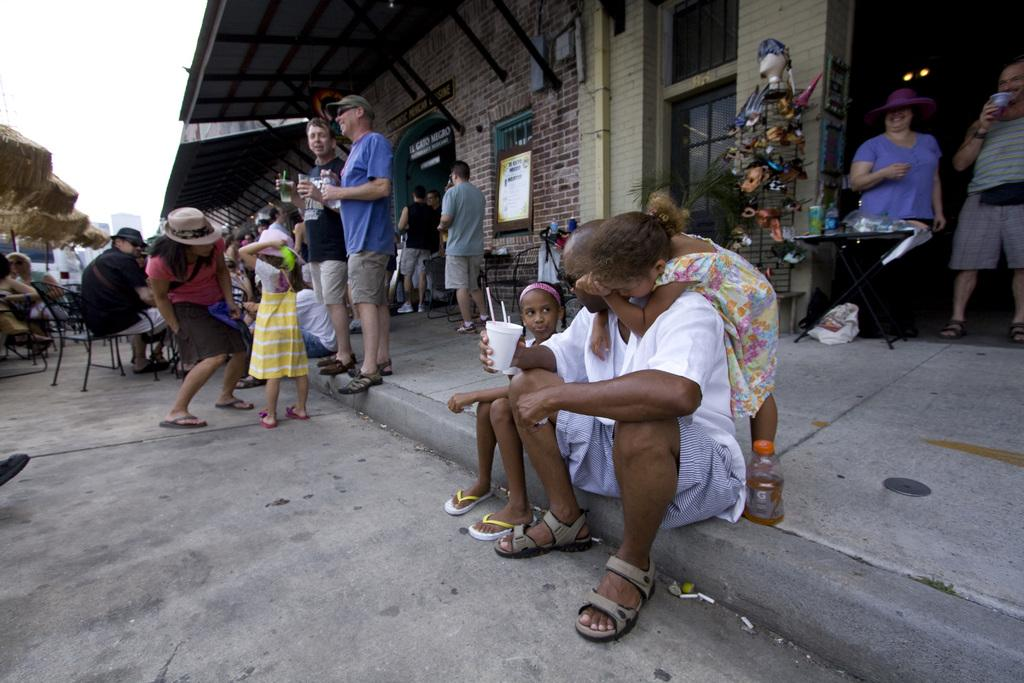What is happening in front of the building in the image? There are people standing and sitting in front of a building. What are some of the people holding in their hands? Some of the people are holding coffee cups in their hands. Can you see any bubbles floating around the people in the image? There are no bubbles visible in the image. 